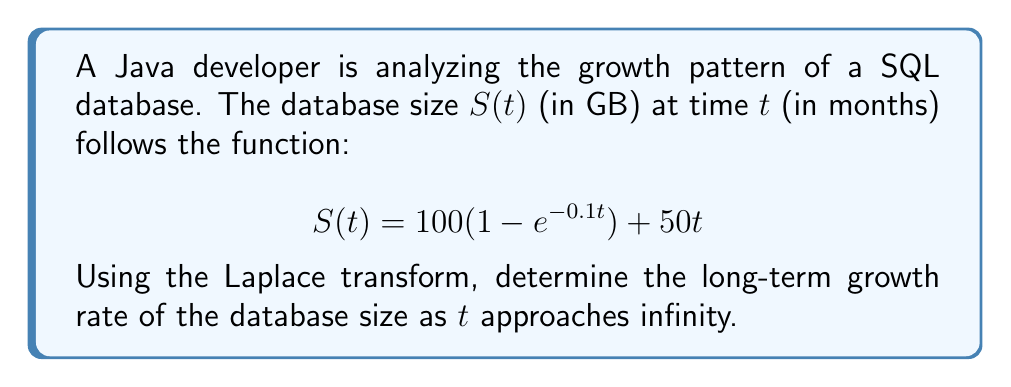Provide a solution to this math problem. To solve this problem, we'll follow these steps:

1) First, let's take the Laplace transform of $S(t)$:

   $$\mathcal{L}\{S(t)\} = \mathcal{L}\{100(1 - e^{-0.1t}) + 50t\}$$

2) Using linearity property of Laplace transform:

   $$\mathcal{L}\{S(t)\} = 100\mathcal{L}\{1 - e^{-0.1t}\} + 50\mathcal{L}\{t\}$$

3) We know that:
   
   $$\mathcal{L}\{1\} = \frac{1}{s}$$
   $$\mathcal{L}\{e^{-at}\} = \frac{1}{s+a}$$
   $$\mathcal{L}\{t\} = \frac{1}{s^2}$$

4) Applying these:

   $$\mathcal{L}\{S(t)\} = 100(\frac{1}{s} - \frac{1}{s+0.1}) + \frac{50}{s^2}$$

5) To find the long-term growth rate, we need to use the Final Value Theorem:

   $$\lim_{t \to \infty} S(t) = \lim_{s \to 0} s\mathcal{L}\{S(t)\}$$

6) Let's calculate this limit:

   $$\lim_{s \to 0} s[100(\frac{1}{s} - \frac{1}{s+0.1}) + \frac{50}{s^2}]$$

7) Simplifying:

   $$\lim_{s \to 0} [100(1 - \frac{s}{s+0.1}) + \frac{50}{s}]$$

8) As $s$ approaches 0, $\frac{s}{s+0.1}$ approaches 0, and $\frac{50}{s}$ approaches infinity.

9) Therefore, the limit is dominated by the $\frac{50}{s}$ term, which represents a linear growth of 50 GB per month.
Answer: The long-term growth rate of the database size is 50 GB per month. 